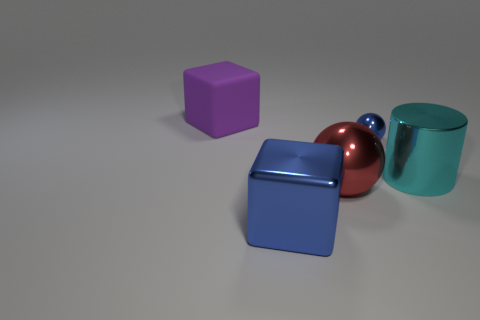Do the tiny object and the big object left of the blue block have the same shape?
Your answer should be very brief. No. There is a big cyan thing; what shape is it?
Offer a terse response. Cylinder. There is a red object that is the same size as the cylinder; what material is it?
Make the answer very short. Metal. Is there anything else that is the same size as the blue sphere?
Your response must be concise. No. What number of objects are either green things or blue things that are in front of the small blue shiny sphere?
Ensure brevity in your answer.  1. There is a cyan object that is the same material as the tiny sphere; what size is it?
Make the answer very short. Large. There is a blue metallic object behind the large cube that is right of the rubber thing; what is its shape?
Keep it short and to the point. Sphere. There is a object that is both in front of the tiny shiny sphere and behind the big red object; how big is it?
Offer a terse response. Large. Are there any purple rubber objects of the same shape as the large blue thing?
Give a very brief answer. Yes. Is there anything else that is the same shape as the big purple thing?
Keep it short and to the point. Yes. 